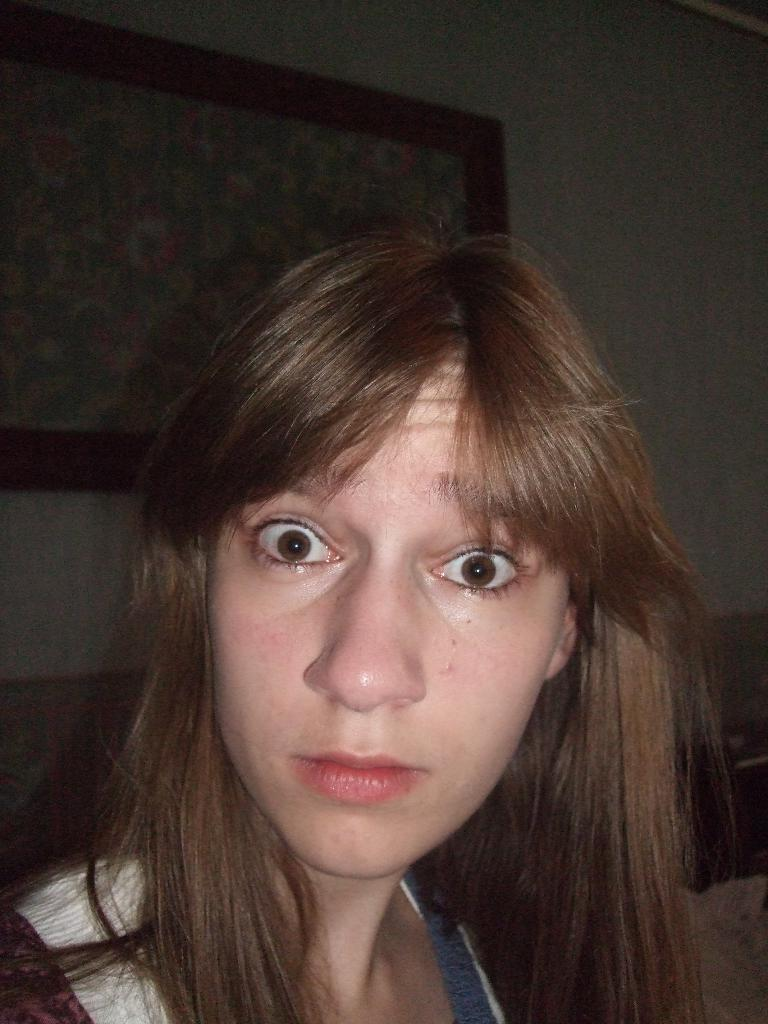Who is present in the image? There is a lady in the image. What can be seen in the background of the image? There is a wall in the background of the image. Is there anything on the wall in the background? Yes, there is a frame placed on the wall in the background. What type of thumb is visible in the image? There is no thumb present in the image. What caused the lady to be in the image? The facts provided do not give any information about the cause of the lady being in the image. Can you see a pig in the image? There is no pig present in the image. 